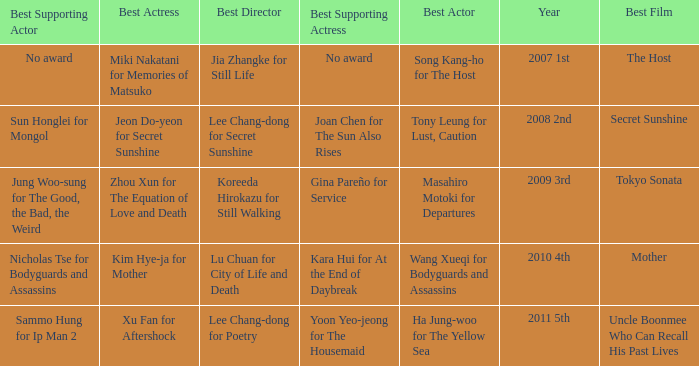Name the best supporting actress for sun honglei for mongol Joan Chen for The Sun Also Rises. 